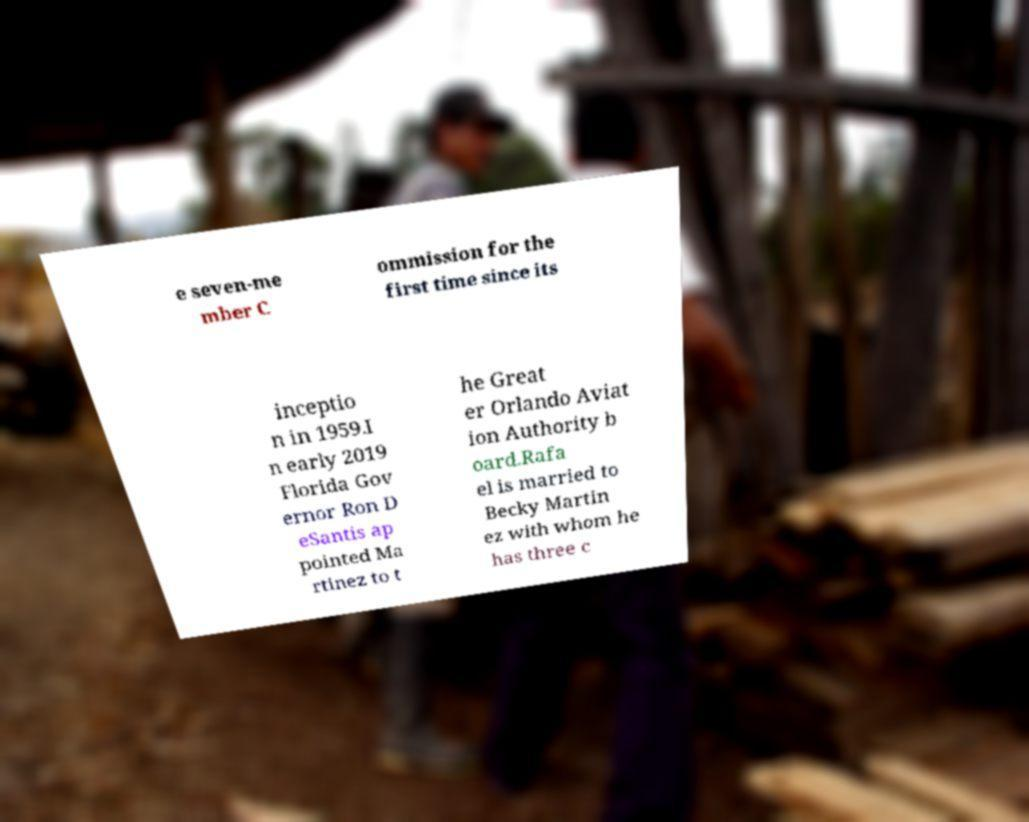Could you extract and type out the text from this image? e seven-me mber C ommission for the first time since its inceptio n in 1959.I n early 2019 Florida Gov ernor Ron D eSantis ap pointed Ma rtinez to t he Great er Orlando Aviat ion Authority b oard.Rafa el is married to Becky Martin ez with whom he has three c 